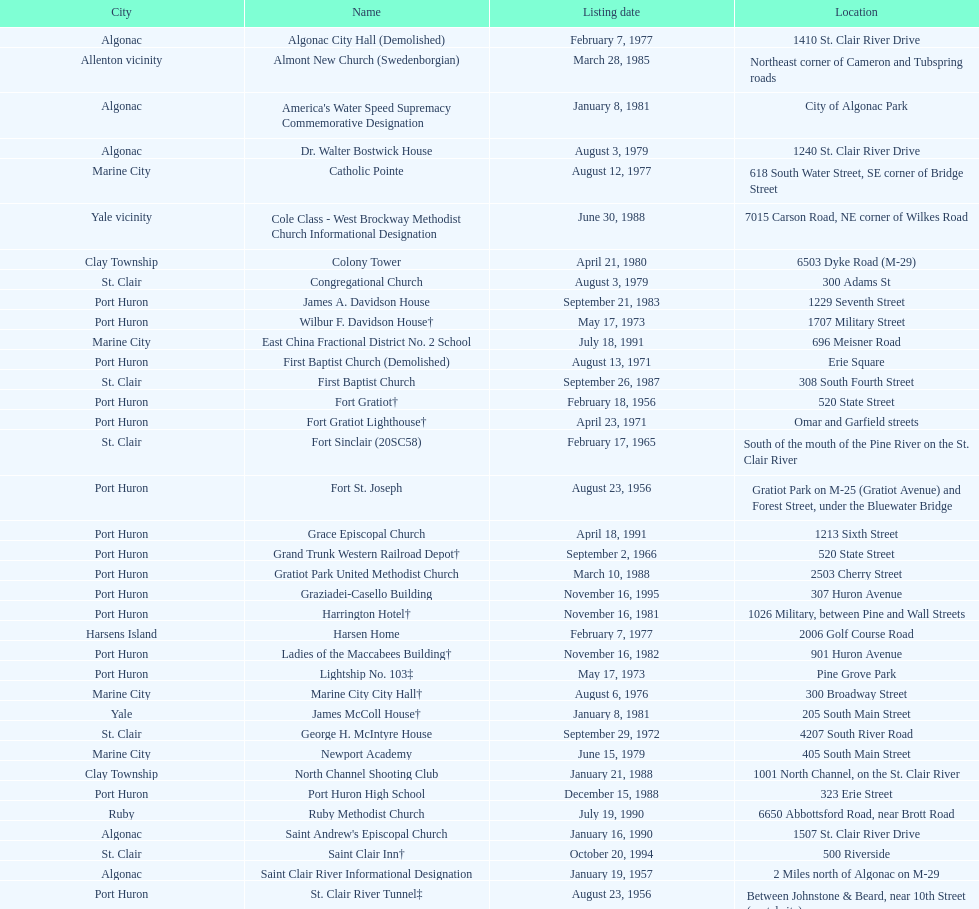How many names do not have images next to them? 41. 